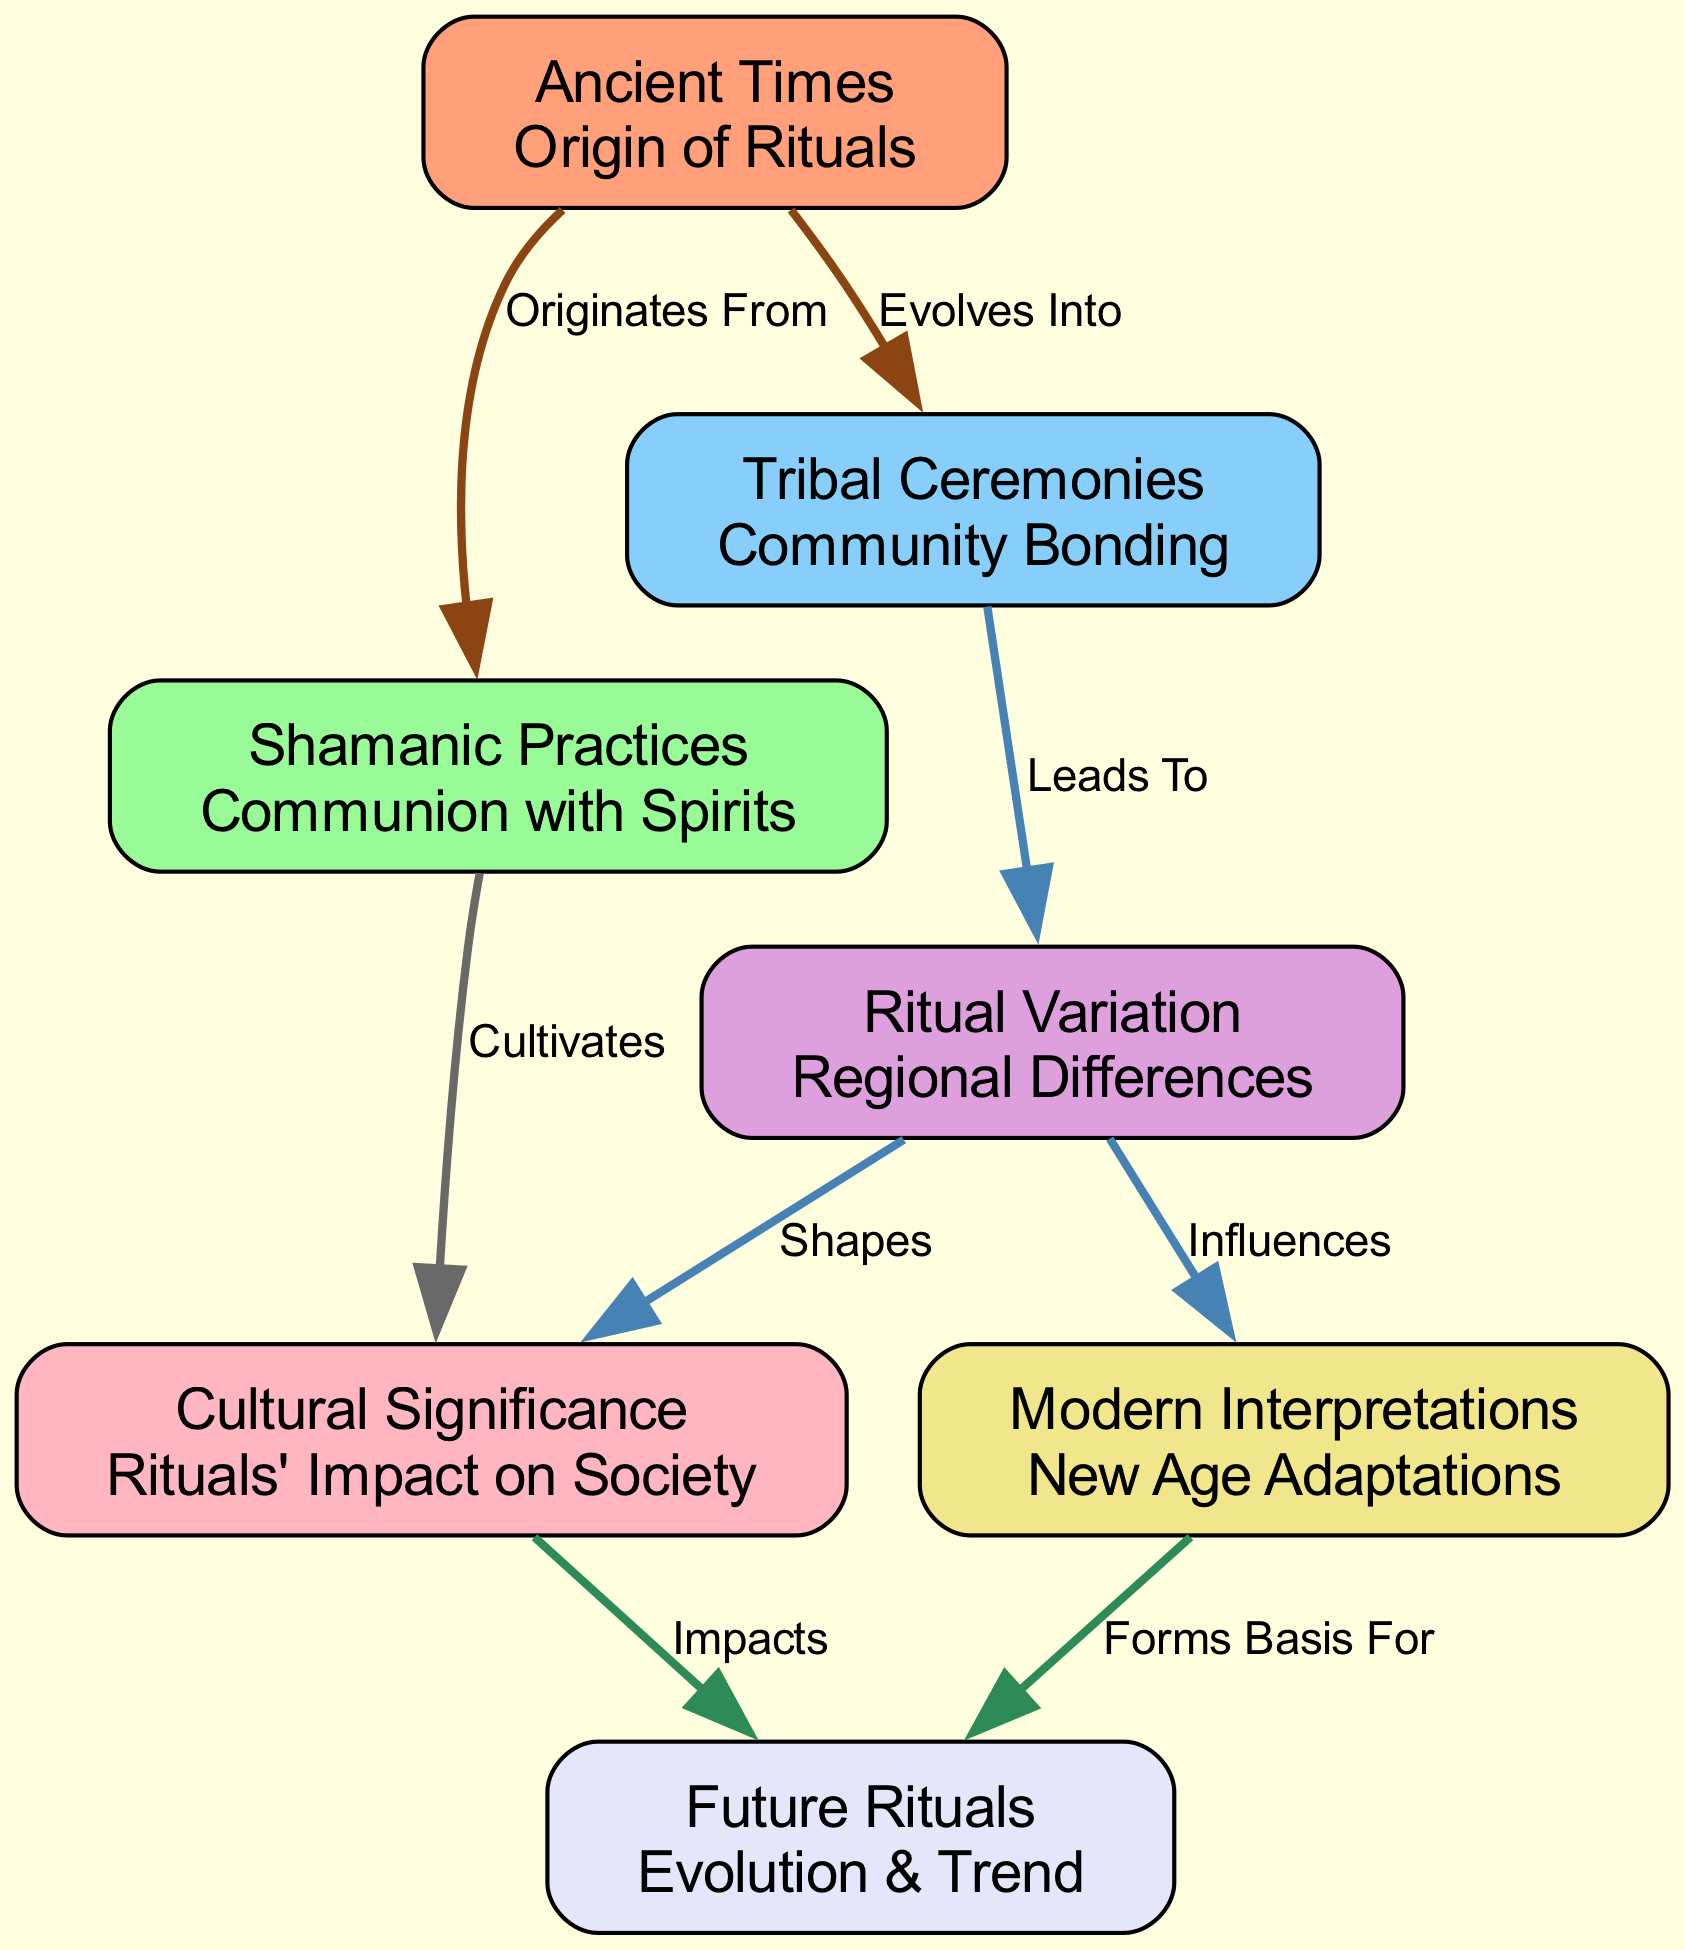What is the first node in the diagram? The first node is labeled "Ancient Times" as it is the origin of rituals and appears at the top of the flowchart.
Answer: Ancient Times How many nodes are there in total? The diagram lists a total of seven nodes, each representing different stages or types of rituals over time.
Answer: 7 What does "Tribal Ceremonies" lead to in the flowchart? "Tribal Ceremonies" leads to "Ritual Variation," indicating that communal practices evolve into differing regional rituals.
Answer: Ritual Variation Which node is influenced by "Ritual Variation"? "Modern Interpretations" is influenced by "Ritual Variation," as indicated by the connection in the flowchart.
Answer: Modern Interpretations What impact does "Cultural Significance" have on future rituals? The flowchart shows that "Cultural Significance" impacts "Future Rituals," suggesting that the societal roles of rituals will shape their evolution.
Answer: Impacts What relationship exists between "Shamanic Practices" and "Cultural Significance"? "Shamanic Practices" cultivates "Cultural Significance," indicating that early spiritual practices contribute to how rituals are valued in culture.
Answer: Cultivates Which node is depicted as evolving from "Ancient Times"? "Tribal Ceremonies" evolves from "Ancient Times," signifying that early practices developed into more complex community rituals.
Answer: Tribal Ceremonies Which edges are described with the label "Shapes"? The edge leading from "Ritual Variation" to "Cultural Significance" is labeled "Shapes," highlighting the influence of variations on cultural roles.
Answer: Shapes What does the node "Future Rituals" represent in the diagram? "Future Rituals" represents the trends and evolution of rituals as shaped by past practices and their significances.
Answer: Evolution & Trend 